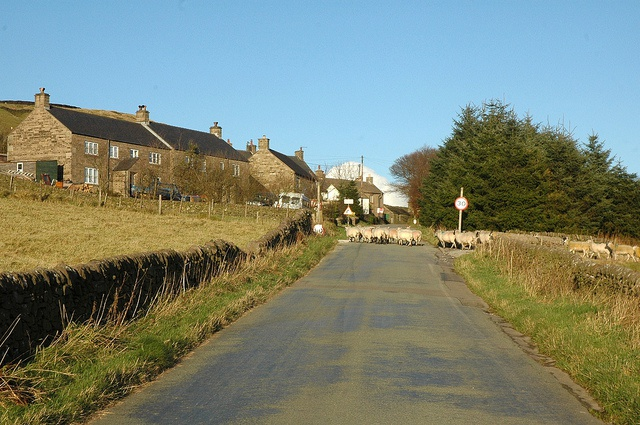Describe the objects in this image and their specific colors. I can see sheep in lightblue, tan, and olive tones, truck in lightblue, olive, gray, and black tones, bus in lightblue, olive, beige, tan, and gray tones, sheep in lightblue, tan, and olive tones, and sheep in lightblue, tan, and olive tones in this image. 